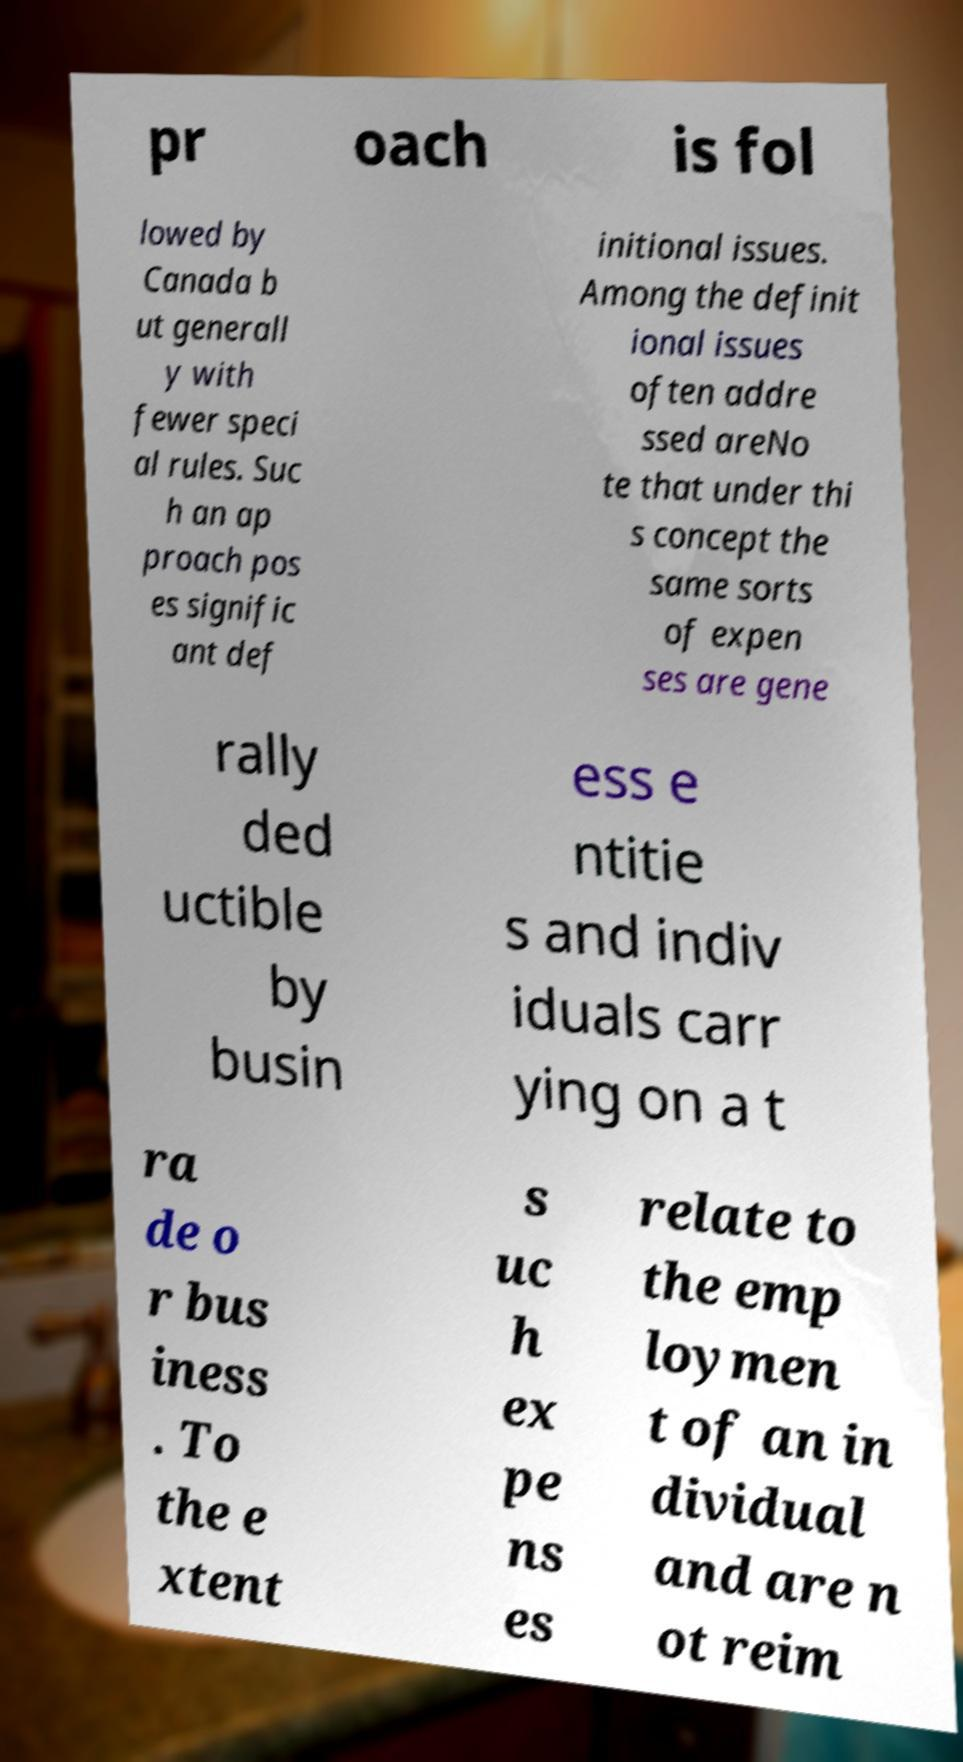Please identify and transcribe the text found in this image. pr oach is fol lowed by Canada b ut generall y with fewer speci al rules. Suc h an ap proach pos es signific ant def initional issues. Among the definit ional issues often addre ssed areNo te that under thi s concept the same sorts of expen ses are gene rally ded uctible by busin ess e ntitie s and indiv iduals carr ying on a t ra de o r bus iness . To the e xtent s uc h ex pe ns es relate to the emp loymen t of an in dividual and are n ot reim 